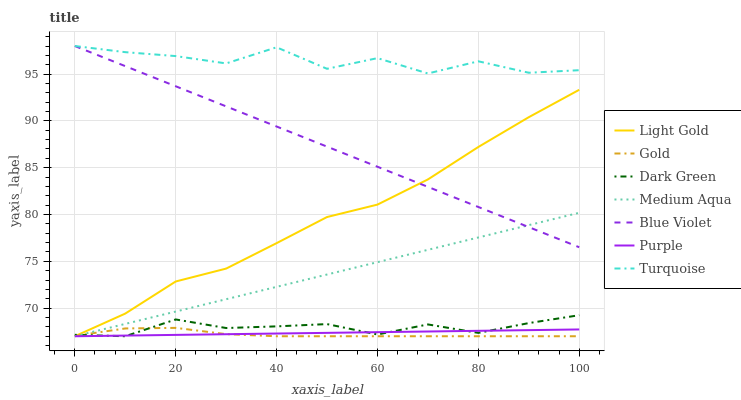Does Gold have the minimum area under the curve?
Answer yes or no. Yes. Does Turquoise have the maximum area under the curve?
Answer yes or no. Yes. Does Purple have the minimum area under the curve?
Answer yes or no. No. Does Purple have the maximum area under the curve?
Answer yes or no. No. Is Medium Aqua the smoothest?
Answer yes or no. Yes. Is Turquoise the roughest?
Answer yes or no. Yes. Is Gold the smoothest?
Answer yes or no. No. Is Gold the roughest?
Answer yes or no. No. Does Gold have the lowest value?
Answer yes or no. Yes. Does Blue Violet have the lowest value?
Answer yes or no. No. Does Blue Violet have the highest value?
Answer yes or no. Yes. Does Gold have the highest value?
Answer yes or no. No. Is Dark Green less than Blue Violet?
Answer yes or no. Yes. Is Turquoise greater than Purple?
Answer yes or no. Yes. Does Medium Aqua intersect Blue Violet?
Answer yes or no. Yes. Is Medium Aqua less than Blue Violet?
Answer yes or no. No. Is Medium Aqua greater than Blue Violet?
Answer yes or no. No. Does Dark Green intersect Blue Violet?
Answer yes or no. No. 